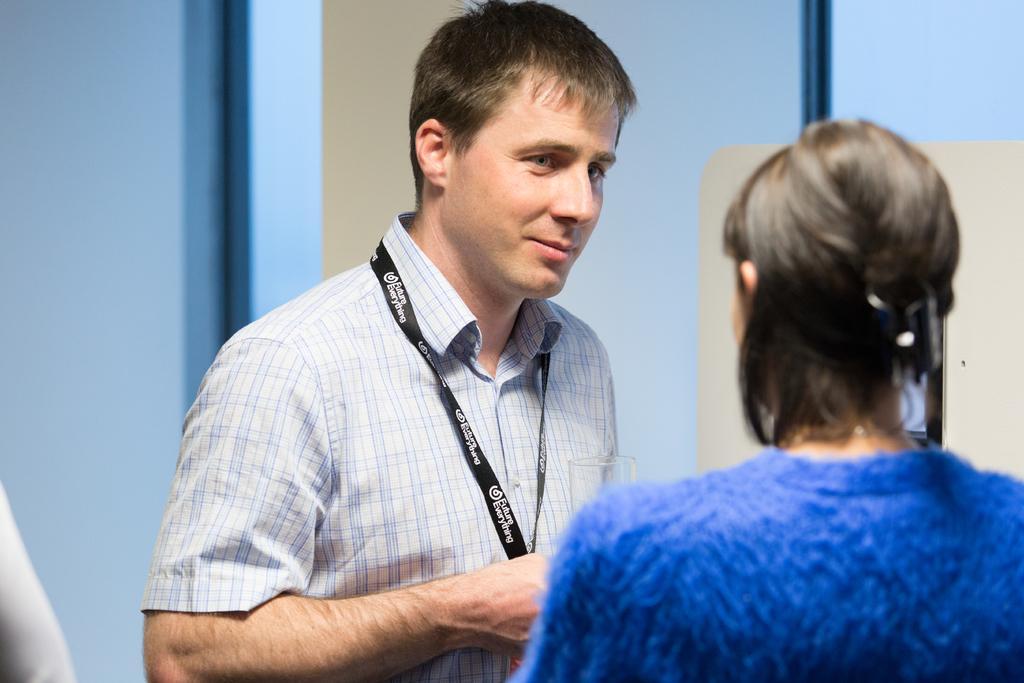Describe this image in one or two sentences. In this image I can see a person wearing white shirt and another person wearing blue colored dress. In the background I can see the blue colored surface, the cream colored surface and to the left bottom of the image I can see a white colored object. 